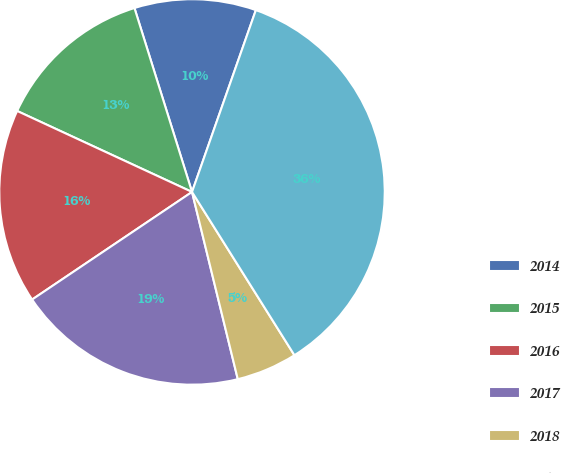<chart> <loc_0><loc_0><loc_500><loc_500><pie_chart><fcel>2014<fcel>2015<fcel>2016<fcel>2017<fcel>2018<fcel>2019-2023<nl><fcel>10.2%<fcel>13.27%<fcel>16.33%<fcel>19.39%<fcel>5.1%<fcel>35.71%<nl></chart> 